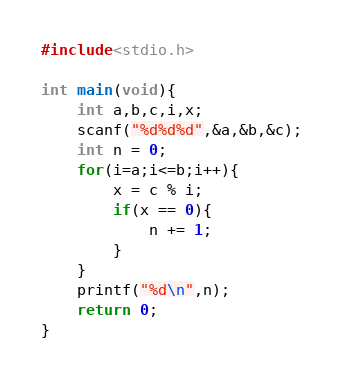Convert code to text. <code><loc_0><loc_0><loc_500><loc_500><_C_>#include<stdio.h>

int main(void){
    int a,b,c,i,x;
    scanf("%d%d%d",&a,&b,&c);
    int n = 0;
    for(i=a;i<=b;i++){
        x = c % i;
        if(x == 0){
            n += 1;
        }
    }
    printf("%d\n",n);
    return 0;
}
</code> 